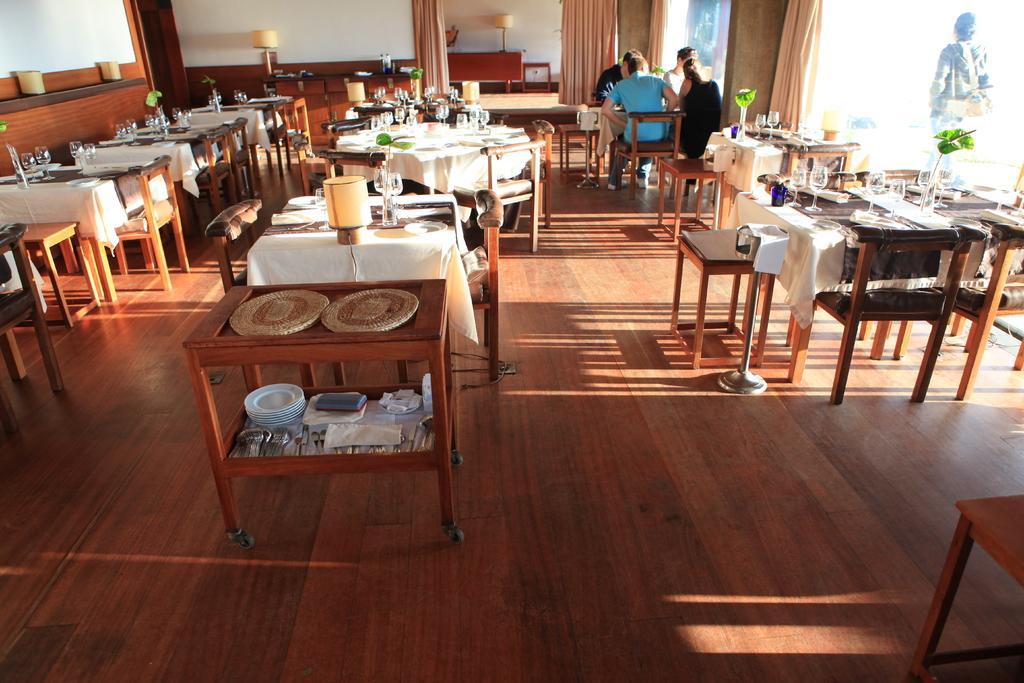Could you give a brief overview of what you see in this image? This picture looks like a restaurant I can see few tables, chairs and I can see clothes, few glasses, plates and napkins on the tables. I can see few people sitting on the chairs and I can see a trolley table with few mats and plates. I can see curtains and few table lamps and from the glass I can see a human walking and looks like a table at the bottom right corner of the picture. 